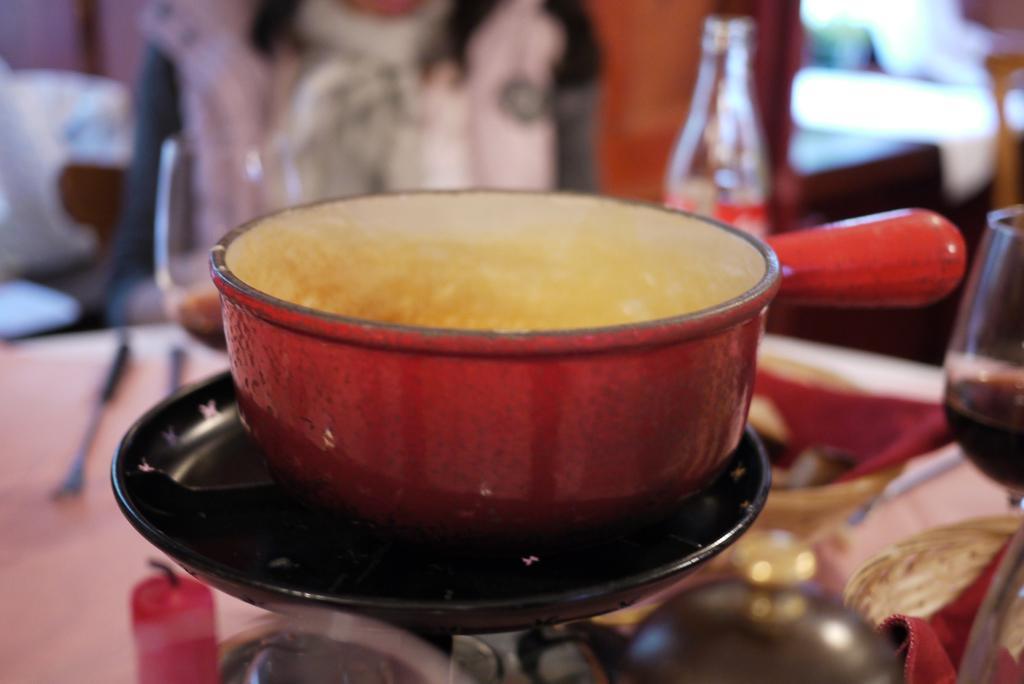Can you describe this image briefly? In this image there is a table. On the table there are glasses, bottles, a pan and a candle. Beside the table there is a person sitting. The background is blurry. 